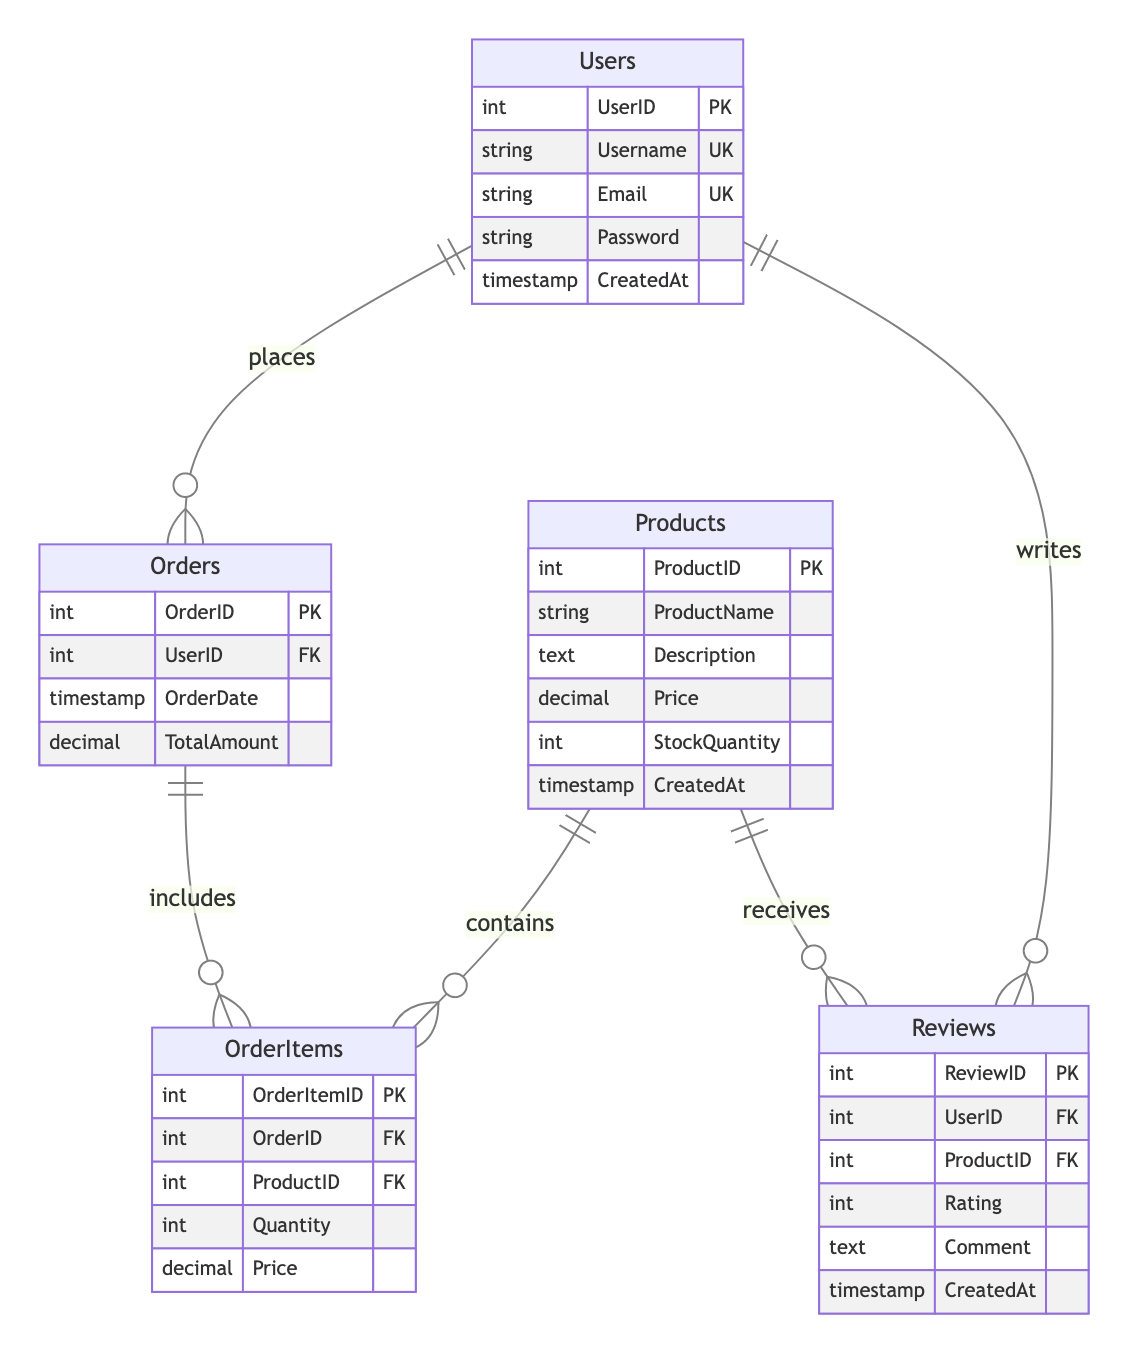What is the primary key of the Users table? The Users table has one primary key, which is indicated by "PK" next to the UserID attribute. The primary key uniquely identifies each user.
Answer: UserID How many foreign keys are present in the Orders table? There is one foreign key in the Orders table, as indicated by "FK" next to the UserID attribute, which refers to the Users table.
Answer: 1 What is the relationship between Products and Reviews? The diagram shows a one-to-many relationship from Products to Reviews, with Products having a "receives" label indicating that a single product can receive multiple reviews from users.
Answer: receives Which table contains the total amount for each order? The total amount for each order is represented in the Orders table, specifically in the TotalAmount attribute. This indicates the financial total of the order placed by a user.
Answer: Orders How many attributes does the Products table have? The Products table includes five attributes: ProductID, ProductName, Description, Price, and StockQuantity, which are listed within the table structure in the diagram.
Answer: 5 What is the mapping between Users and Orders? The mapping shows that a user can place multiple orders, as indicated by the relationship line connecting Users to Orders, marked with "places."
Answer: one-to-many What is the role of the OrderItems table in the diagram? The OrderItems table acts as a junction table that links Orders and Products, containing multiple entries for each order that include product details and quantities.
Answer: junction table What timestamp attribute is present in the Reviews table? The Reviews table includes a CreatedAt attribute, which stores the timestamp representing when a review was created by a user.
Answer: CreatedAt 